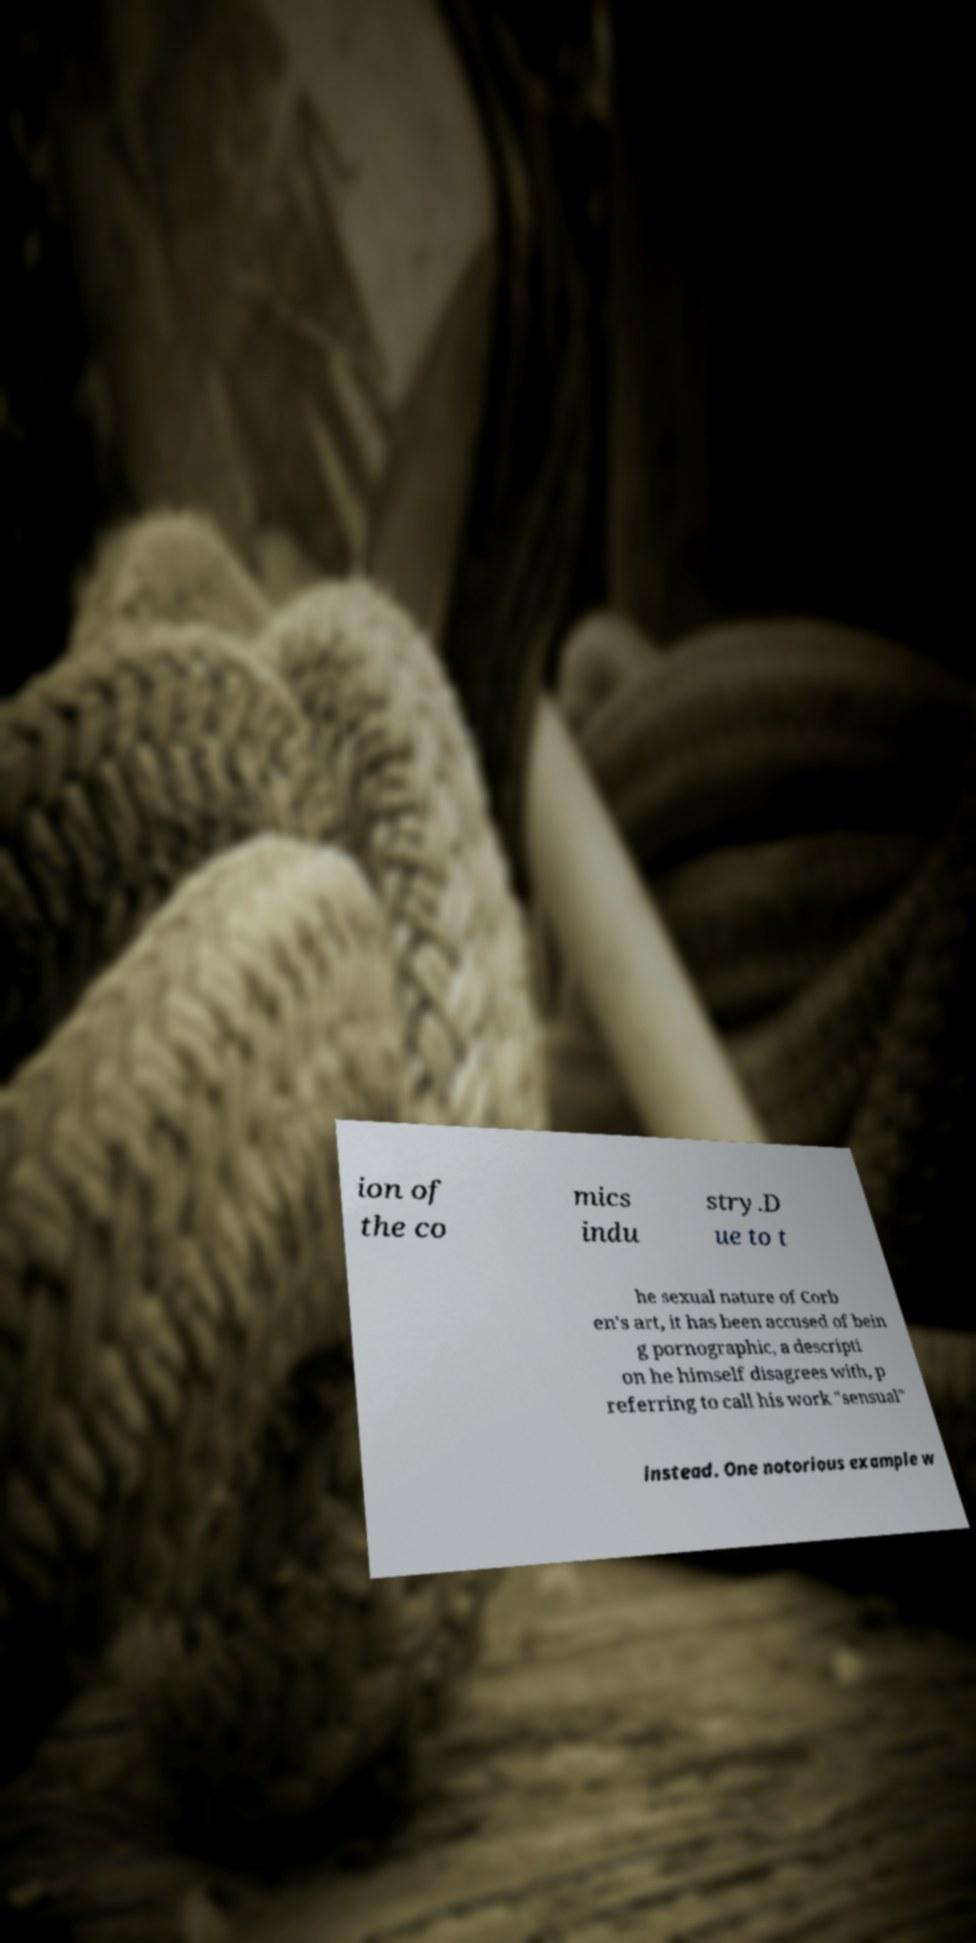Please identify and transcribe the text found in this image. ion of the co mics indu stry.D ue to t he sexual nature of Corb en's art, it has been accused of bein g pornographic, a descripti on he himself disagrees with, p referring to call his work "sensual" instead. One notorious example w 